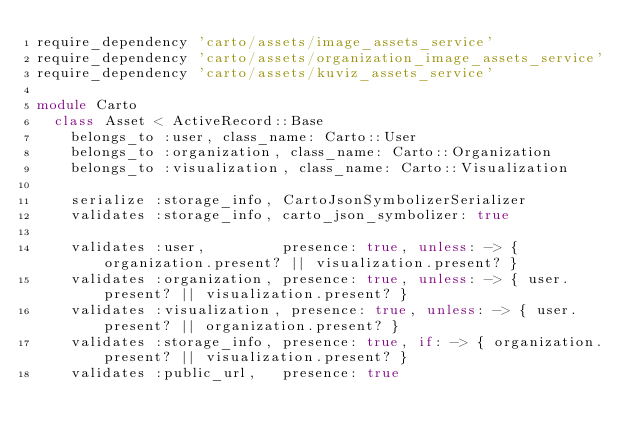<code> <loc_0><loc_0><loc_500><loc_500><_Ruby_>require_dependency 'carto/assets/image_assets_service'
require_dependency 'carto/assets/organization_image_assets_service'
require_dependency 'carto/assets/kuviz_assets_service'

module Carto
  class Asset < ActiveRecord::Base
    belongs_to :user, class_name: Carto::User
    belongs_to :organization, class_name: Carto::Organization
    belongs_to :visualization, class_name: Carto::Visualization

    serialize :storage_info, CartoJsonSymbolizerSerializer
    validates :storage_info, carto_json_symbolizer: true

    validates :user,         presence: true, unless: -> { organization.present? || visualization.present? }
    validates :organization, presence: true, unless: -> { user.present? || visualization.present? }
    validates :visualization, presence: true, unless: -> { user.present? || organization.present? }
    validates :storage_info, presence: true, if: -> { organization.present? || visualization.present? }
    validates :public_url,   presence: true
</code> 